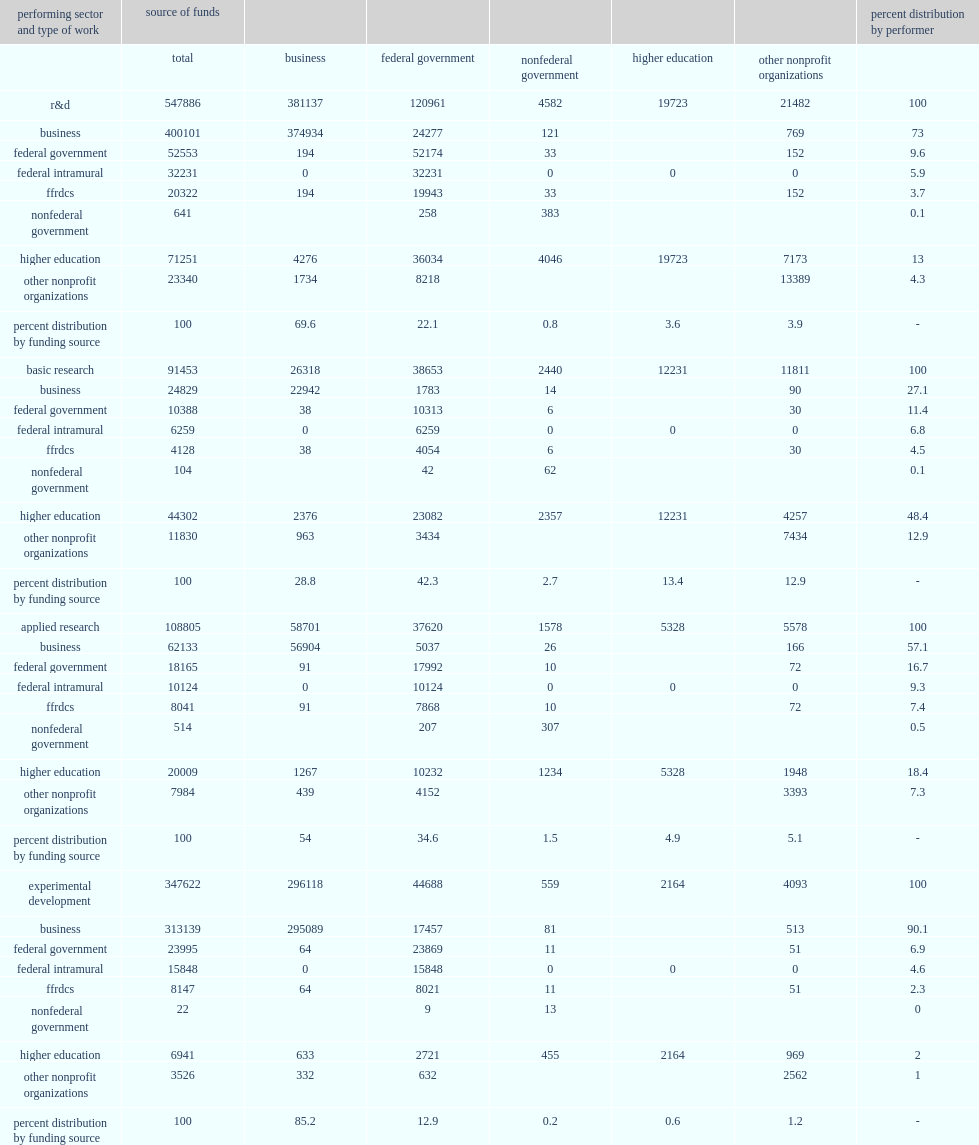In 2017, how many million dollars did domestically performed business r&d account for of the $547.9 million national r&d total? 400101.0. In 2017, how many percent did domestically performed business r&d account for of the $547.9 billion national r&d total? 73.0. 